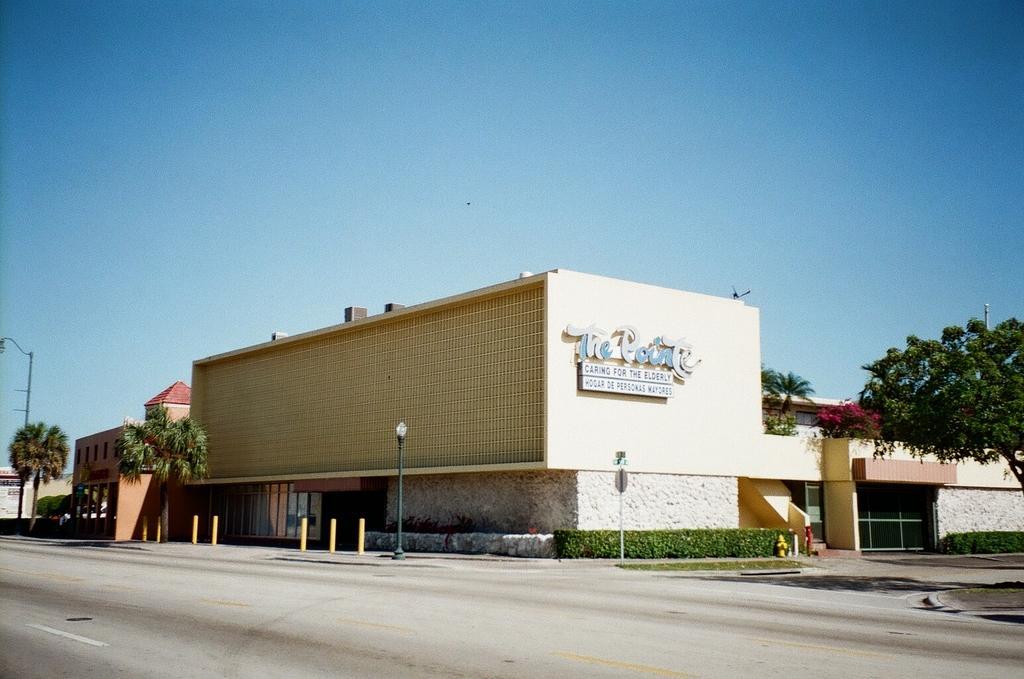Describe this image in one or two sentences. In this image we can see few buildings, a building with text, and few trees, a light pole, a pole with board, few rods, plants and a road on front of the building and the sky on the top. 